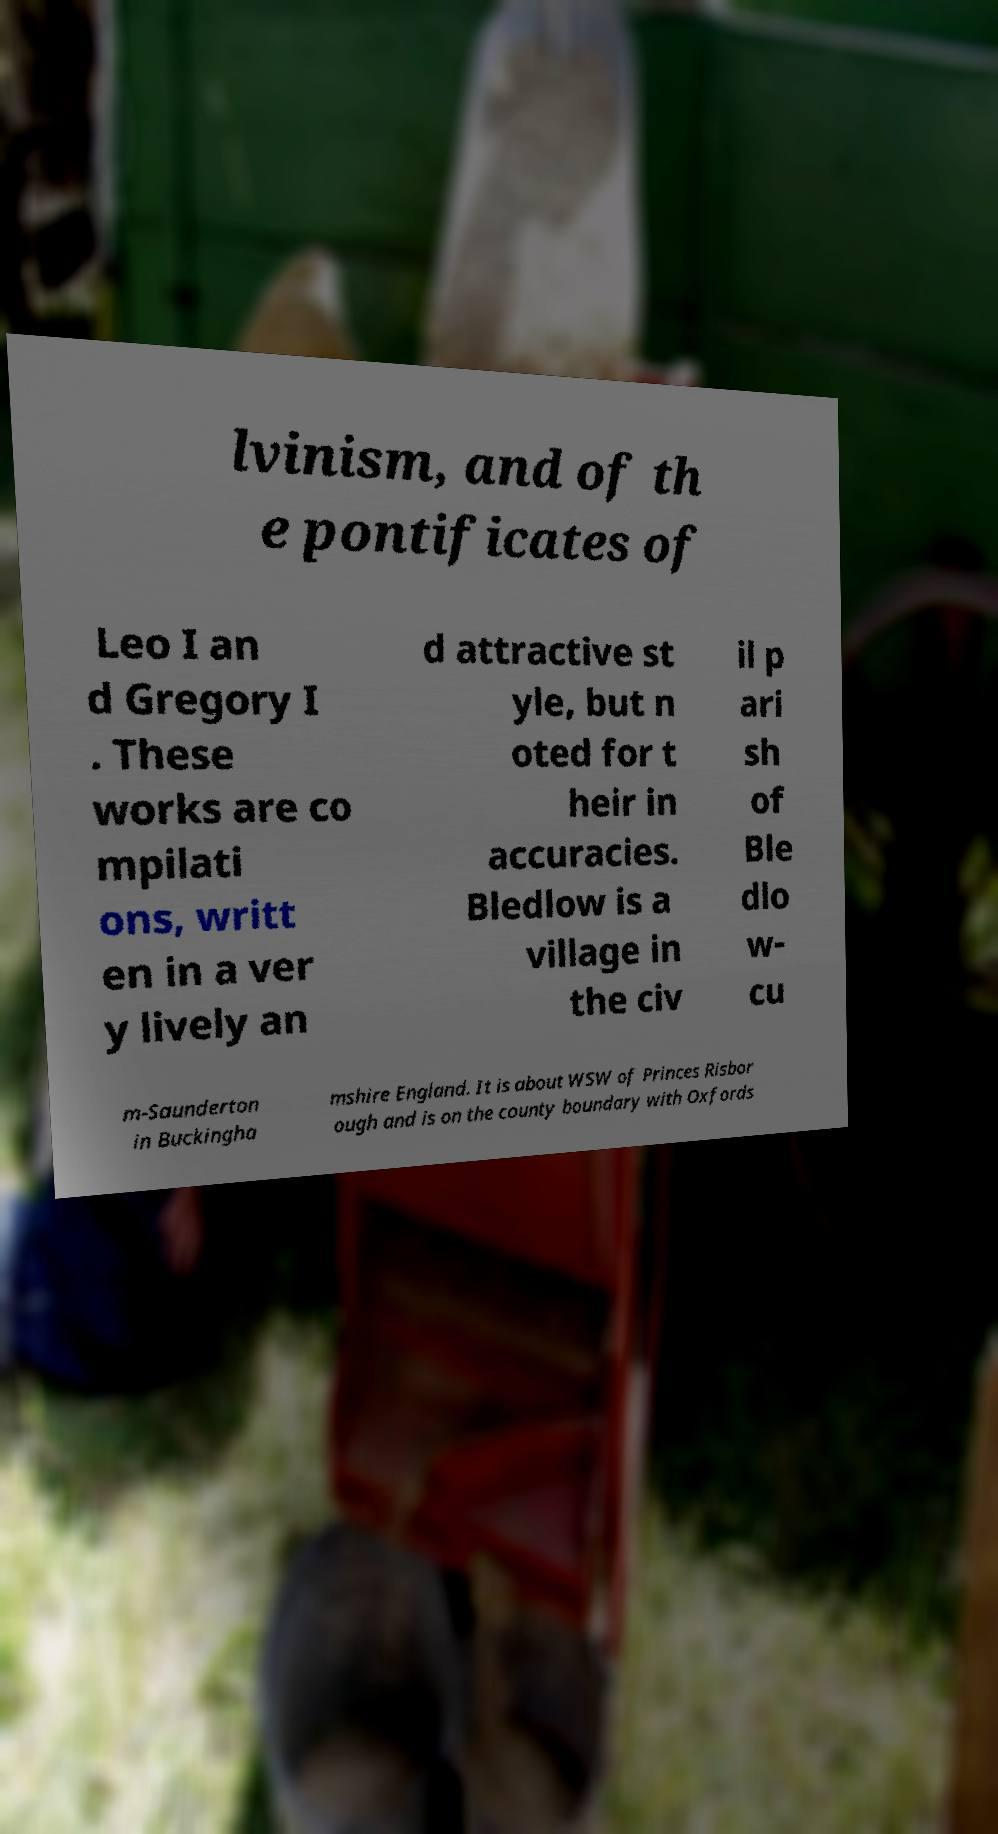For documentation purposes, I need the text within this image transcribed. Could you provide that? lvinism, and of th e pontificates of Leo I an d Gregory I . These works are co mpilati ons, writt en in a ver y lively an d attractive st yle, but n oted for t heir in accuracies. Bledlow is a village in the civ il p ari sh of Ble dlo w- cu m-Saunderton in Buckingha mshire England. It is about WSW of Princes Risbor ough and is on the county boundary with Oxfords 